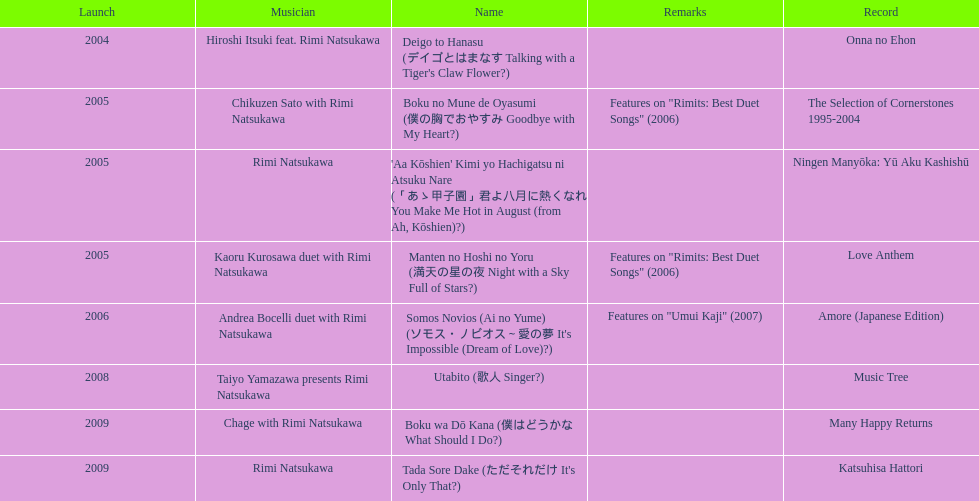Give me the full table as a dictionary. {'header': ['Launch', 'Musician', 'Name', 'Remarks', 'Record'], 'rows': [['2004', 'Hiroshi Itsuki feat. Rimi Natsukawa', "Deigo to Hanasu (デイゴとはまなす Talking with a Tiger's Claw Flower?)", '', 'Onna no Ehon'], ['2005', 'Chikuzen Sato with Rimi Natsukawa', 'Boku no Mune de Oyasumi (僕の胸でおやすみ Goodbye with My Heart?)', 'Features on "Rimits: Best Duet Songs" (2006)', 'The Selection of Cornerstones 1995-2004'], ['2005', 'Rimi Natsukawa', "'Aa Kōshien' Kimi yo Hachigatsu ni Atsuku Nare (「あゝ甲子園」君よ八月に熱くなれ You Make Me Hot in August (from Ah, Kōshien)?)", '', 'Ningen Manyōka: Yū Aku Kashishū'], ['2005', 'Kaoru Kurosawa duet with Rimi Natsukawa', 'Manten no Hoshi no Yoru (満天の星の夜 Night with a Sky Full of Stars?)', 'Features on "Rimits: Best Duet Songs" (2006)', 'Love Anthem'], ['2006', 'Andrea Bocelli duet with Rimi Natsukawa', "Somos Novios (Ai no Yume) (ソモス・ノビオス～愛の夢 It's Impossible (Dream of Love)?)", 'Features on "Umui Kaji" (2007)', 'Amore (Japanese Edition)'], ['2008', 'Taiyo Yamazawa presents Rimi Natsukawa', 'Utabito (歌人 Singer?)', '', 'Music Tree'], ['2009', 'Chage with Rimi Natsukawa', 'Boku wa Dō Kana (僕はどうかな What Should I Do?)', '', 'Many Happy Returns'], ['2009', 'Rimi Natsukawa', "Tada Sore Dake (ただそれだけ It's Only That?)", '', 'Katsuhisa Hattori']]} Which title has the same notes as night with a sky full of stars? Boku no Mune de Oyasumi (僕の胸でおやすみ Goodbye with My Heart?). 